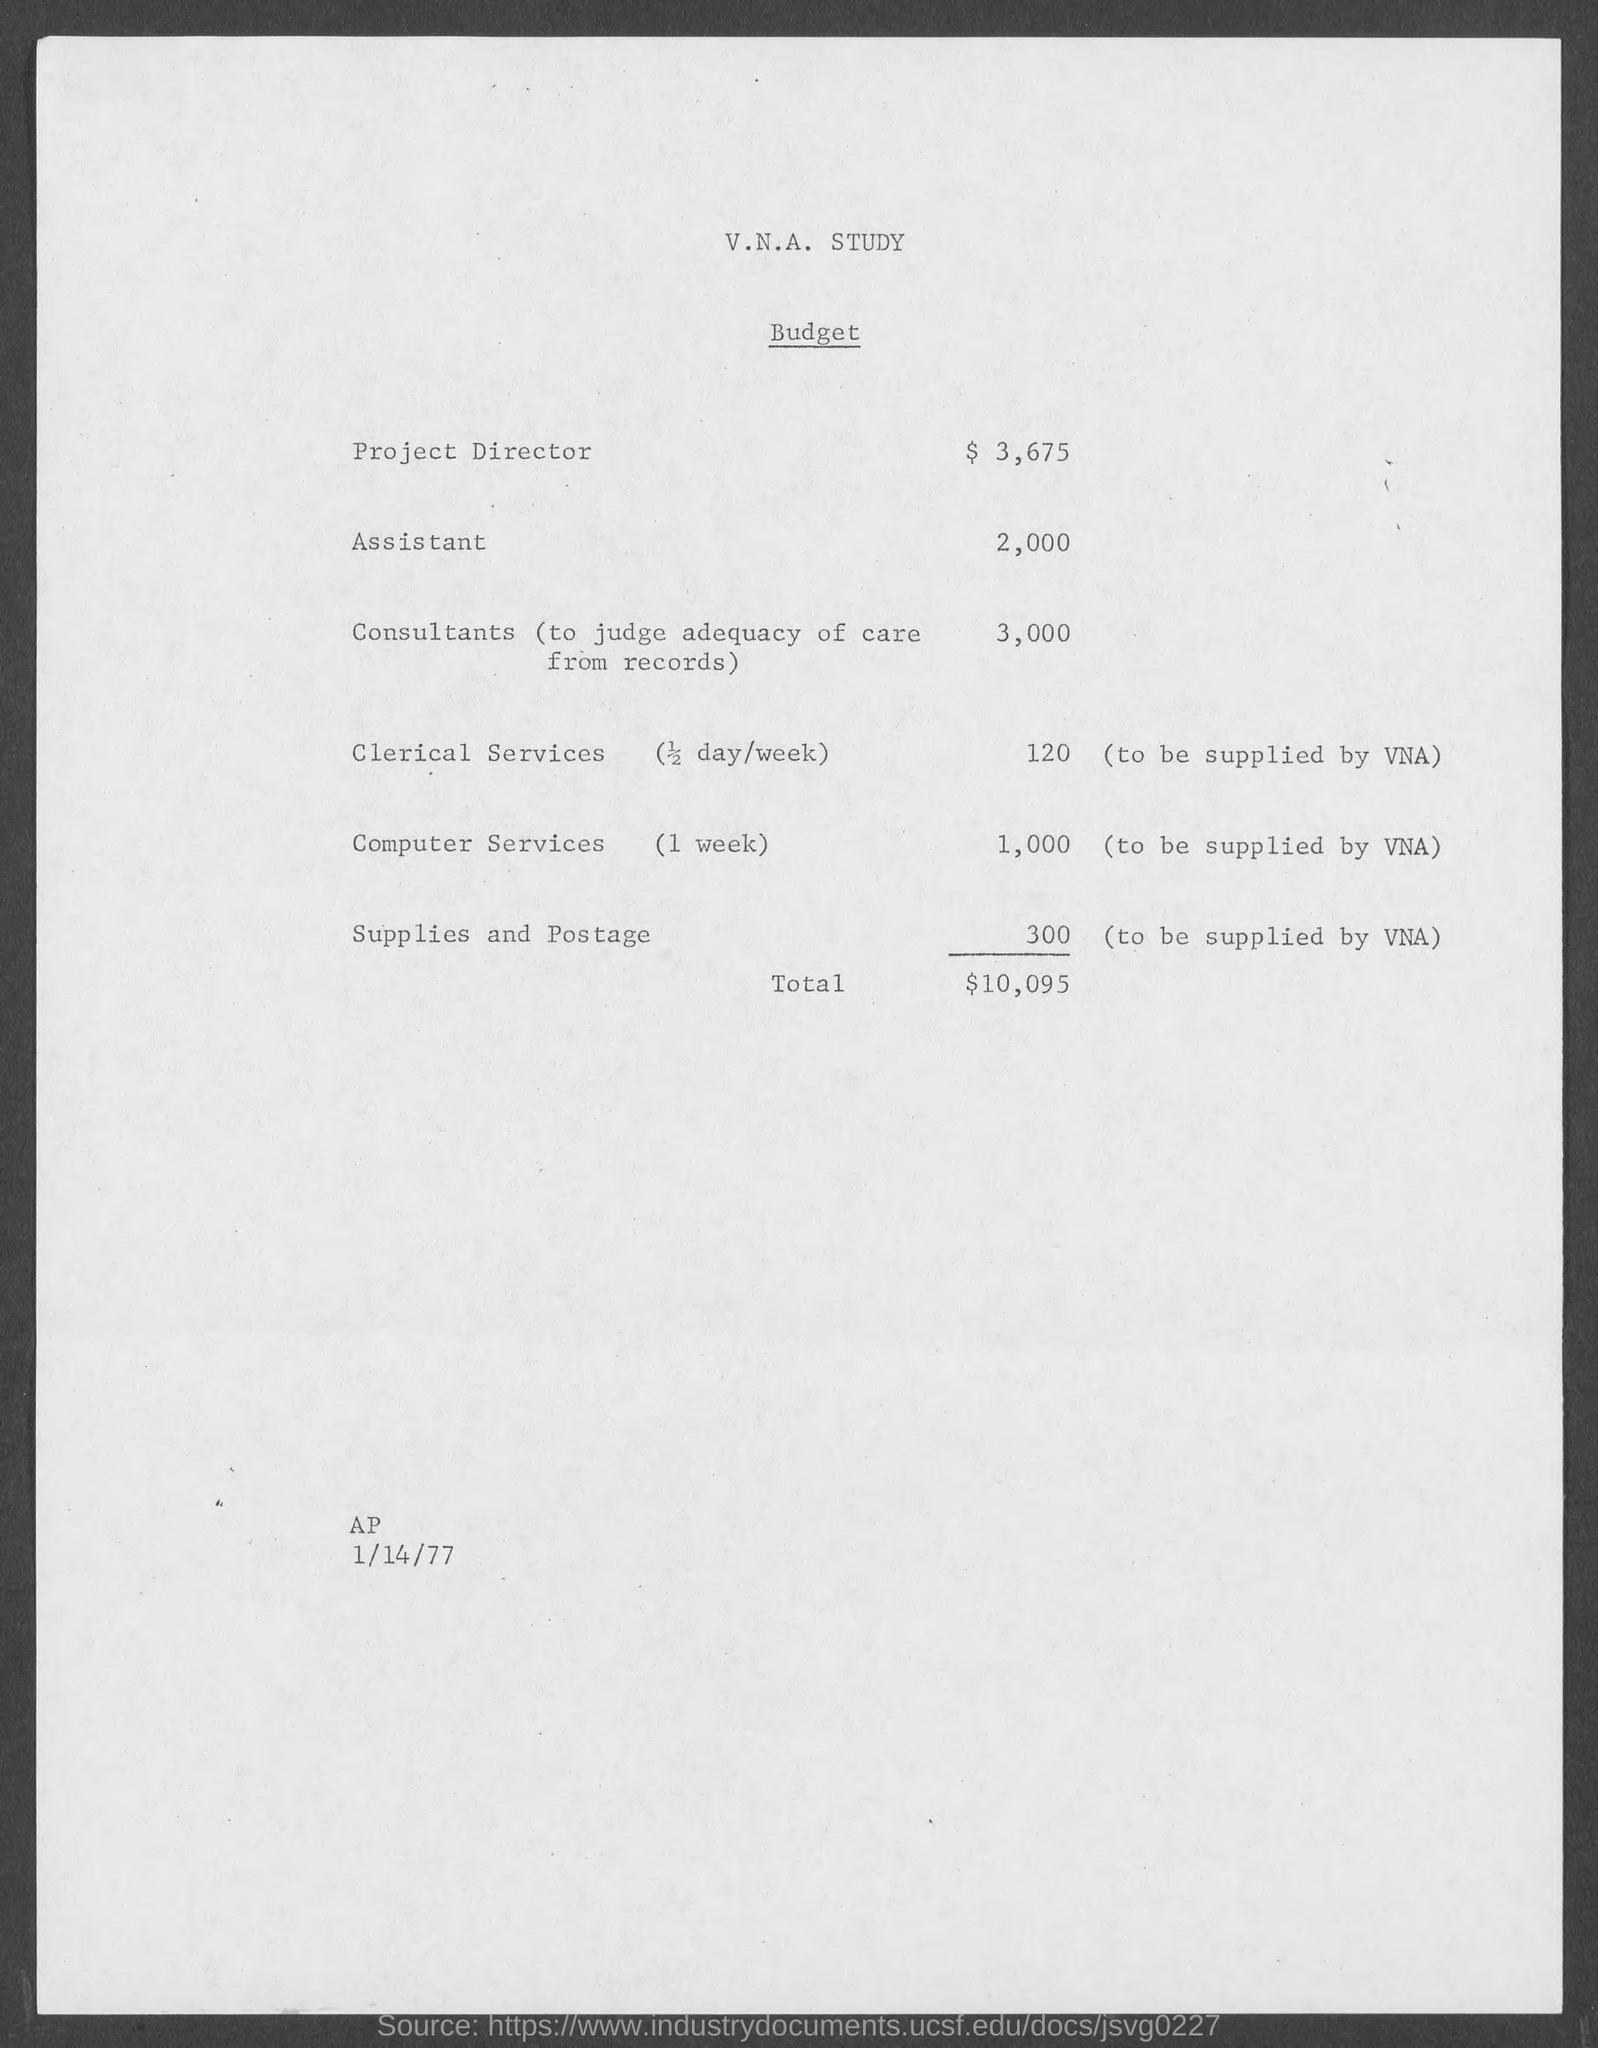Specify some key components in this picture. The budget estimate for the Project Director is 3,675. The total budget estimate mentioned in the document is 10,095. The date mentioned in the document is January 14, 1977. 